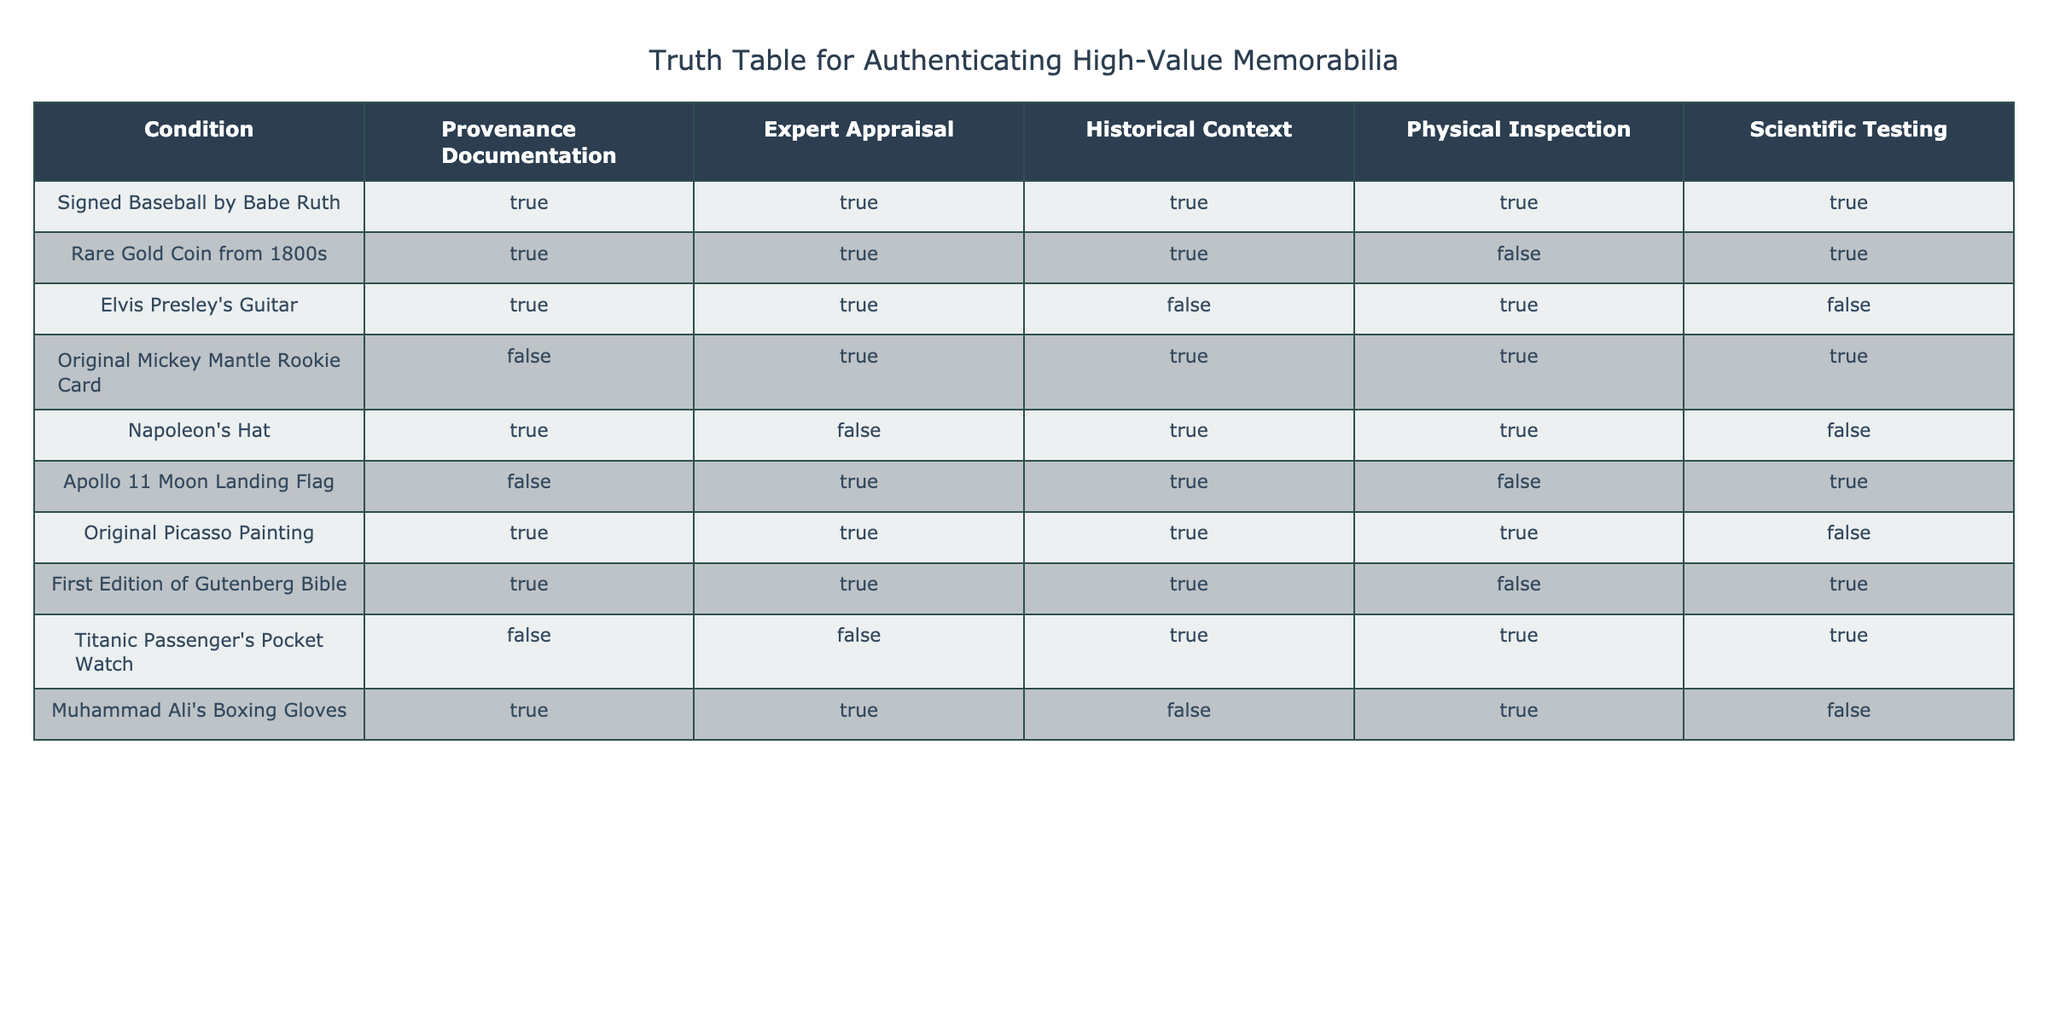What memorabilia have both Provenance Documentation and Expert Appraisal? To answer this, I will examine each row in the table for both 'TRUE' values in the "Provenance Documentation" and "Expert Appraisal" columns. The memorabilia that meet this criteria are: "Signed Baseball by Babe Ruth," "Rare Gold Coin from 1800s," "Elvis Presley's Guitar," "Original Picasso Painting," and "First Edition of Gutenberg Bible."
Answer: Signed Baseball by Babe Ruth, Rare Gold Coin from 1800s, Elvis Presley's Guitar, Original Picasso Painting, First Edition of Gutenberg Bible Which memorabilia does not have Scientific Testing? I will look through the "Scientific Testing" column and find entries marked as 'FALSE.' The items that do not have scientific testing are: "Rare Gold Coin from 1800s," "Elvis Presley's Guitar," "Napoleon's Hat," "Apollo 11 Moon Landing Flag," "Muhammad Ali's Boxing Gloves."
Answer: Rare Gold Coin from 1800s, Elvis Presley's Guitar, Napoleon's Hat, Apollo 11 Moon Landing Flag, Muhammad Ali's Boxing Gloves How many items have Historical Context as TRUE and Provenance Documentation as FALSE? I will iterate through the rows in the table, count how many items have "Historical Context" as 'TRUE' and "Provenance Documentation" as 'FALSE.' The items that fit both criteria are: "Original Mickey Mantle Rookie Card" and "Titanic Passenger's Pocket Watch." The total count is 2.
Answer: 2 Is the Original Picasso Painting authenticated based on all conditions? I will check each condition related to the "Original Picasso Painting." It has 'TRUE' for Provenance Documentation, Expert Appraisal, Historical Context, and Physical Inspection, but 'FALSE' for Scientific Testing. Therefore, it is not authenticated based on all conditions.
Answer: No What percentage of items have a Physical Inspection as TRUE? To find this, I will count the total number of memorabilia (10) and how many have 'TRUE' in the "Physical Inspection" column (6). The percentage is (6/10) * 100%, which gives 60%.
Answer: 60% Which two items have both Historical Context and Physical Inspection as TRUE, but lack Scientific Testing? I will first filter for items with 'TRUE' in both "Historical Context" and "Physical Inspection" columns, then check which of those have 'FALSE' for "Scientific Testing." The items that satisfy these conditions are "Titanic Passenger's Pocket Watch" and "Apollo 11 Moon Landing Flag."
Answer: Titanic Passenger's Pocket Watch, Apollo 11 Moon Landing Flag How many memorabilia can be confirmed by only Provenance Documentation and an Expert Appraisal? I will look for memorabilia that have 'TRUE' for both "Provenance Documentation" and "Expert Appraisal," but must have at least one of the other three conditions as 'FALSE.' The items that satisfy this are "Rare Gold Coin from 1800s," "Elvis Presley's Guitar," and "Muhammad Ali's Boxing Gloves," leading to a total of 3 items.
Answer: 3 Which item is the only one categorized with a FALSE Provenance Documentation but TRUE Historical Context? I will check each item to identify one with 'FALSE' for "Provenance Documentation" and 'TRUE' for "Historical Context." The only item to meet this condition is "Titanic Passenger's Pocket Watch."
Answer: Titanic Passenger's Pocket Watch 